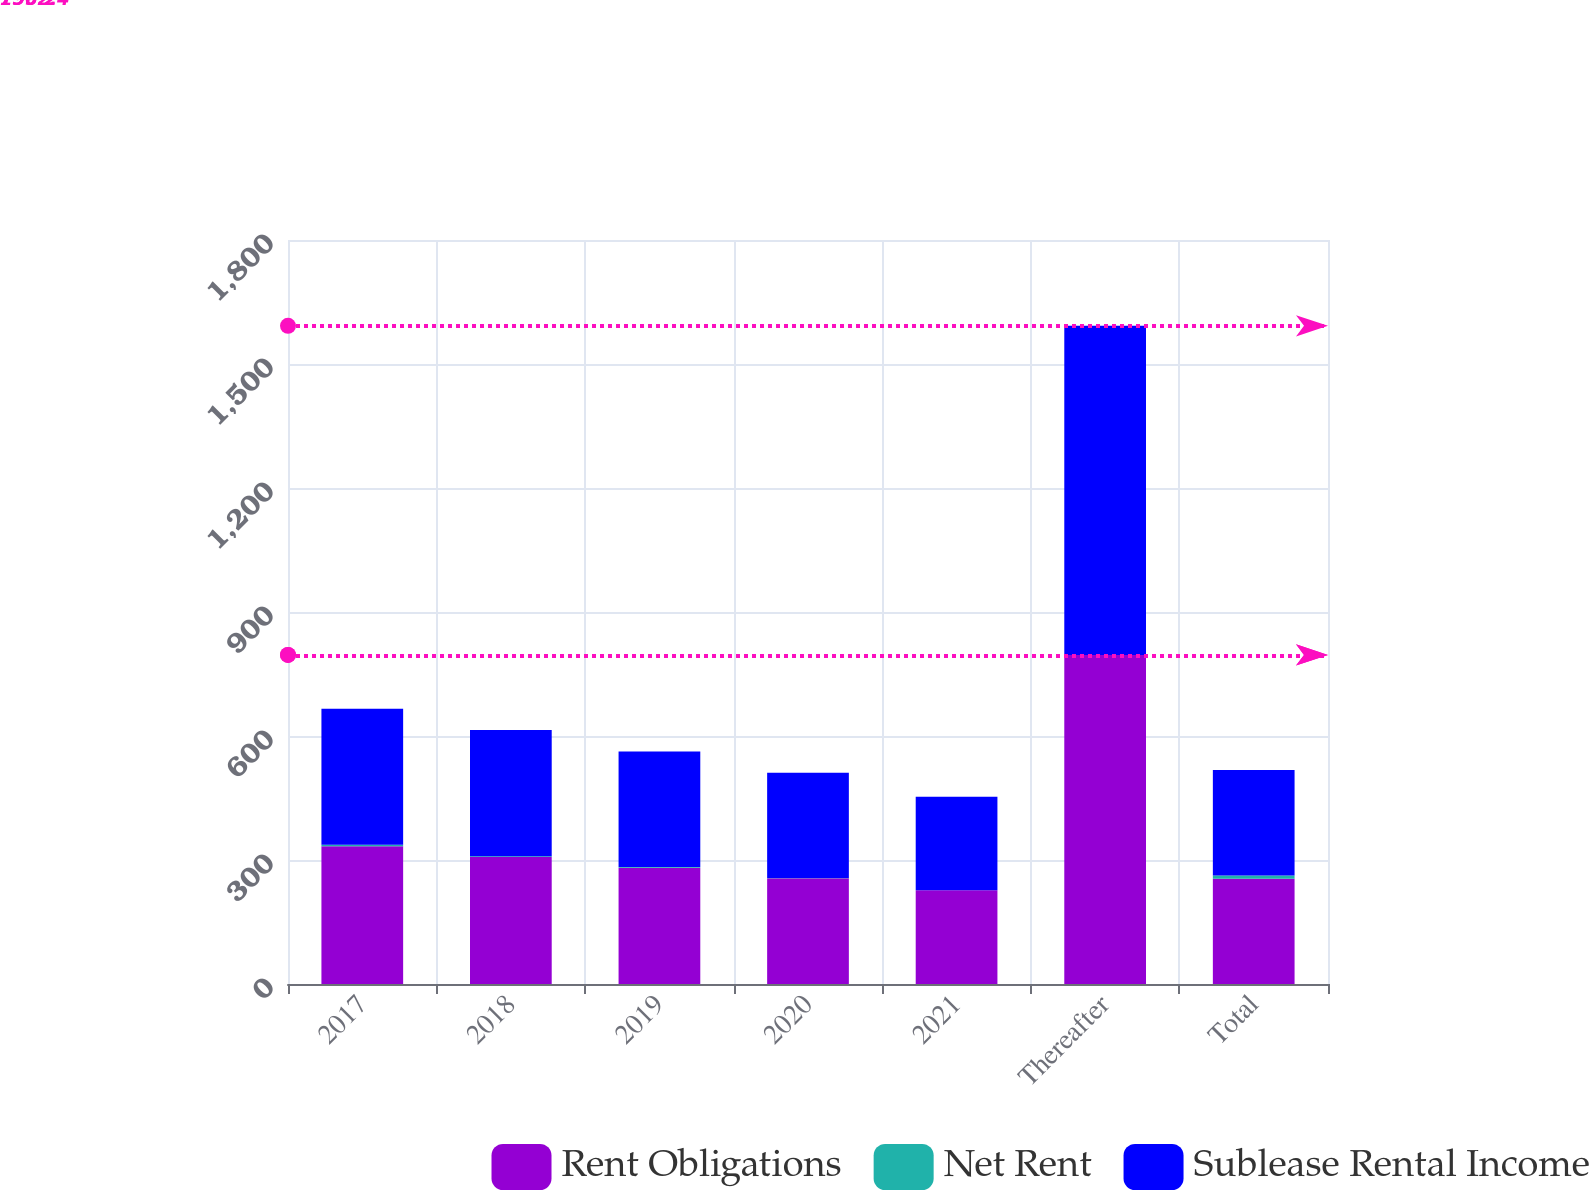Convert chart to OTSL. <chart><loc_0><loc_0><loc_500><loc_500><stacked_bar_chart><ecel><fcel>2017<fcel>2018<fcel>2019<fcel>2020<fcel>2021<fcel>Thereafter<fcel>Total<nl><fcel>Rent Obligations<fcel>333<fcel>307.2<fcel>281.4<fcel>255.6<fcel>226.6<fcel>796.2<fcel>254.8<nl><fcel>Net Rent<fcel>3.6<fcel>1.7<fcel>1.6<fcel>0.8<fcel>0.2<fcel>0<fcel>7.9<nl><fcel>Sublease Rental Income<fcel>329.4<fcel>305.5<fcel>279.8<fcel>254.8<fcel>226.4<fcel>796.2<fcel>254.8<nl></chart> 